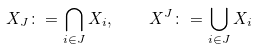<formula> <loc_0><loc_0><loc_500><loc_500>X _ { J } \colon = \bigcap _ { i \in J } X _ { i } , \quad X ^ { J } \colon = \bigcup _ { i \in J } X _ { i }</formula> 